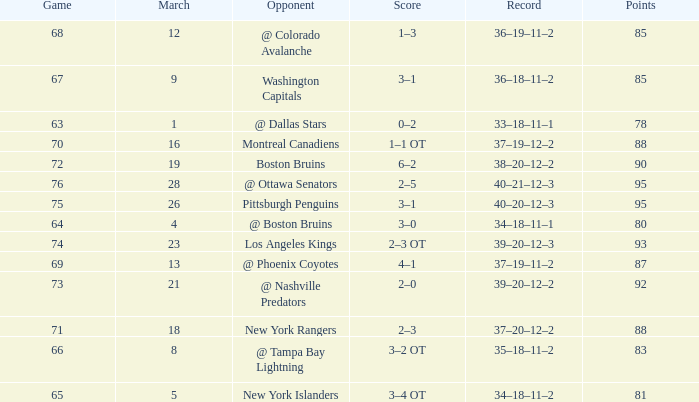Which Opponent has a Record of 38–20–12–2? Boston Bruins. 